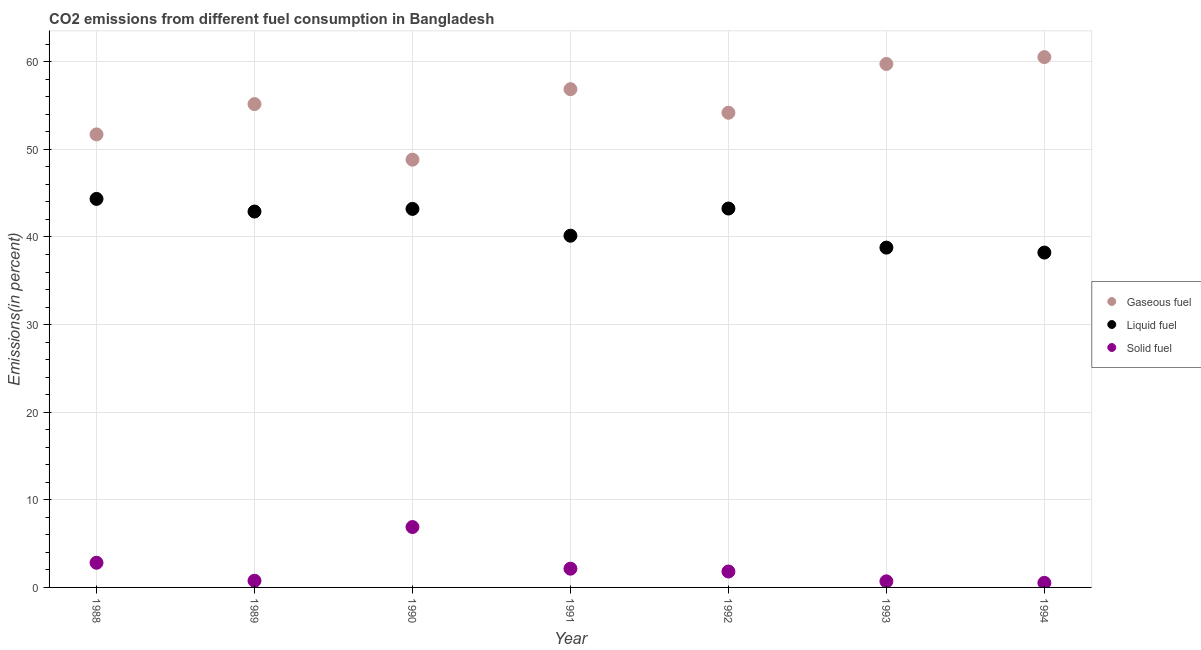How many different coloured dotlines are there?
Ensure brevity in your answer.  3. What is the percentage of liquid fuel emission in 1989?
Provide a short and direct response. 42.9. Across all years, what is the maximum percentage of liquid fuel emission?
Make the answer very short. 44.34. Across all years, what is the minimum percentage of liquid fuel emission?
Your answer should be very brief. 38.22. What is the total percentage of solid fuel emission in the graph?
Keep it short and to the point. 15.65. What is the difference between the percentage of liquid fuel emission in 1991 and that in 1993?
Offer a terse response. 1.36. What is the difference between the percentage of liquid fuel emission in 1994 and the percentage of gaseous fuel emission in 1993?
Offer a very short reply. -21.53. What is the average percentage of gaseous fuel emission per year?
Provide a short and direct response. 55.29. In the year 1988, what is the difference between the percentage of gaseous fuel emission and percentage of liquid fuel emission?
Give a very brief answer. 7.36. What is the ratio of the percentage of gaseous fuel emission in 1992 to that in 1994?
Your response must be concise. 0.9. Is the percentage of solid fuel emission in 1991 less than that in 1994?
Your answer should be compact. No. Is the difference between the percentage of liquid fuel emission in 1992 and 1993 greater than the difference between the percentage of solid fuel emission in 1992 and 1993?
Provide a succinct answer. Yes. What is the difference between the highest and the second highest percentage of gaseous fuel emission?
Give a very brief answer. 0.78. What is the difference between the highest and the lowest percentage of liquid fuel emission?
Offer a terse response. 6.12. Is the sum of the percentage of solid fuel emission in 1990 and 1992 greater than the maximum percentage of gaseous fuel emission across all years?
Make the answer very short. No. Does the percentage of solid fuel emission monotonically increase over the years?
Ensure brevity in your answer.  No. Is the percentage of gaseous fuel emission strictly greater than the percentage of liquid fuel emission over the years?
Make the answer very short. Yes. Are the values on the major ticks of Y-axis written in scientific E-notation?
Provide a short and direct response. No. Does the graph contain any zero values?
Give a very brief answer. No. How many legend labels are there?
Provide a succinct answer. 3. What is the title of the graph?
Give a very brief answer. CO2 emissions from different fuel consumption in Bangladesh. What is the label or title of the Y-axis?
Make the answer very short. Emissions(in percent). What is the Emissions(in percent) in Gaseous fuel in 1988?
Your response must be concise. 51.71. What is the Emissions(in percent) of Liquid fuel in 1988?
Ensure brevity in your answer.  44.34. What is the Emissions(in percent) in Solid fuel in 1988?
Provide a short and direct response. 2.82. What is the Emissions(in percent) in Gaseous fuel in 1989?
Offer a terse response. 55.16. What is the Emissions(in percent) of Liquid fuel in 1989?
Your answer should be compact. 42.9. What is the Emissions(in percent) in Solid fuel in 1989?
Provide a succinct answer. 0.76. What is the Emissions(in percent) of Gaseous fuel in 1990?
Your response must be concise. 48.82. What is the Emissions(in percent) in Liquid fuel in 1990?
Offer a terse response. 43.2. What is the Emissions(in percent) of Solid fuel in 1990?
Your answer should be very brief. 6.89. What is the Emissions(in percent) in Gaseous fuel in 1991?
Offer a terse response. 56.87. What is the Emissions(in percent) of Liquid fuel in 1991?
Provide a succinct answer. 40.14. What is the Emissions(in percent) in Solid fuel in 1991?
Give a very brief answer. 2.14. What is the Emissions(in percent) in Gaseous fuel in 1992?
Your response must be concise. 54.17. What is the Emissions(in percent) in Liquid fuel in 1992?
Offer a very short reply. 43.24. What is the Emissions(in percent) in Solid fuel in 1992?
Offer a very short reply. 1.82. What is the Emissions(in percent) of Gaseous fuel in 1993?
Make the answer very short. 59.74. What is the Emissions(in percent) of Liquid fuel in 1993?
Provide a succinct answer. 38.78. What is the Emissions(in percent) in Solid fuel in 1993?
Offer a very short reply. 0.7. What is the Emissions(in percent) of Gaseous fuel in 1994?
Keep it short and to the point. 60.53. What is the Emissions(in percent) in Liquid fuel in 1994?
Provide a short and direct response. 38.22. What is the Emissions(in percent) of Solid fuel in 1994?
Your answer should be very brief. 0.52. Across all years, what is the maximum Emissions(in percent) of Gaseous fuel?
Give a very brief answer. 60.53. Across all years, what is the maximum Emissions(in percent) of Liquid fuel?
Your answer should be very brief. 44.34. Across all years, what is the maximum Emissions(in percent) in Solid fuel?
Give a very brief answer. 6.89. Across all years, what is the minimum Emissions(in percent) in Gaseous fuel?
Keep it short and to the point. 48.82. Across all years, what is the minimum Emissions(in percent) in Liquid fuel?
Give a very brief answer. 38.22. Across all years, what is the minimum Emissions(in percent) of Solid fuel?
Provide a succinct answer. 0.52. What is the total Emissions(in percent) in Gaseous fuel in the graph?
Your response must be concise. 387. What is the total Emissions(in percent) in Liquid fuel in the graph?
Ensure brevity in your answer.  290.83. What is the total Emissions(in percent) of Solid fuel in the graph?
Provide a short and direct response. 15.65. What is the difference between the Emissions(in percent) in Gaseous fuel in 1988 and that in 1989?
Offer a very short reply. -3.46. What is the difference between the Emissions(in percent) in Liquid fuel in 1988 and that in 1989?
Keep it short and to the point. 1.44. What is the difference between the Emissions(in percent) of Solid fuel in 1988 and that in 1989?
Provide a short and direct response. 2.05. What is the difference between the Emissions(in percent) of Gaseous fuel in 1988 and that in 1990?
Your answer should be compact. 2.89. What is the difference between the Emissions(in percent) in Liquid fuel in 1988 and that in 1990?
Give a very brief answer. 1.14. What is the difference between the Emissions(in percent) of Solid fuel in 1988 and that in 1990?
Your response must be concise. -4.08. What is the difference between the Emissions(in percent) of Gaseous fuel in 1988 and that in 1991?
Your answer should be very brief. -5.16. What is the difference between the Emissions(in percent) in Liquid fuel in 1988 and that in 1991?
Offer a very short reply. 4.2. What is the difference between the Emissions(in percent) in Solid fuel in 1988 and that in 1991?
Your answer should be very brief. 0.68. What is the difference between the Emissions(in percent) in Gaseous fuel in 1988 and that in 1992?
Give a very brief answer. -2.47. What is the difference between the Emissions(in percent) of Liquid fuel in 1988 and that in 1992?
Your response must be concise. 1.1. What is the difference between the Emissions(in percent) in Solid fuel in 1988 and that in 1992?
Provide a succinct answer. 1. What is the difference between the Emissions(in percent) of Gaseous fuel in 1988 and that in 1993?
Make the answer very short. -8.04. What is the difference between the Emissions(in percent) of Liquid fuel in 1988 and that in 1993?
Offer a very short reply. 5.56. What is the difference between the Emissions(in percent) of Solid fuel in 1988 and that in 1993?
Your answer should be compact. 2.12. What is the difference between the Emissions(in percent) of Gaseous fuel in 1988 and that in 1994?
Provide a succinct answer. -8.82. What is the difference between the Emissions(in percent) of Liquid fuel in 1988 and that in 1994?
Offer a terse response. 6.12. What is the difference between the Emissions(in percent) in Solid fuel in 1988 and that in 1994?
Offer a very short reply. 2.29. What is the difference between the Emissions(in percent) of Gaseous fuel in 1989 and that in 1990?
Offer a terse response. 6.35. What is the difference between the Emissions(in percent) of Liquid fuel in 1989 and that in 1990?
Keep it short and to the point. -0.3. What is the difference between the Emissions(in percent) of Solid fuel in 1989 and that in 1990?
Your response must be concise. -6.13. What is the difference between the Emissions(in percent) in Gaseous fuel in 1989 and that in 1991?
Your response must be concise. -1.7. What is the difference between the Emissions(in percent) of Liquid fuel in 1989 and that in 1991?
Keep it short and to the point. 2.76. What is the difference between the Emissions(in percent) of Solid fuel in 1989 and that in 1991?
Provide a short and direct response. -1.38. What is the difference between the Emissions(in percent) in Gaseous fuel in 1989 and that in 1992?
Offer a terse response. 0.99. What is the difference between the Emissions(in percent) in Liquid fuel in 1989 and that in 1992?
Offer a terse response. -0.34. What is the difference between the Emissions(in percent) in Solid fuel in 1989 and that in 1992?
Your response must be concise. -1.05. What is the difference between the Emissions(in percent) in Gaseous fuel in 1989 and that in 1993?
Offer a terse response. -4.58. What is the difference between the Emissions(in percent) in Liquid fuel in 1989 and that in 1993?
Keep it short and to the point. 4.12. What is the difference between the Emissions(in percent) of Solid fuel in 1989 and that in 1993?
Your response must be concise. 0.07. What is the difference between the Emissions(in percent) of Gaseous fuel in 1989 and that in 1994?
Offer a terse response. -5.36. What is the difference between the Emissions(in percent) of Liquid fuel in 1989 and that in 1994?
Give a very brief answer. 4.68. What is the difference between the Emissions(in percent) of Solid fuel in 1989 and that in 1994?
Provide a short and direct response. 0.24. What is the difference between the Emissions(in percent) of Gaseous fuel in 1990 and that in 1991?
Your response must be concise. -8.05. What is the difference between the Emissions(in percent) of Liquid fuel in 1990 and that in 1991?
Your answer should be compact. 3.06. What is the difference between the Emissions(in percent) of Solid fuel in 1990 and that in 1991?
Offer a terse response. 4.75. What is the difference between the Emissions(in percent) in Gaseous fuel in 1990 and that in 1992?
Offer a terse response. -5.35. What is the difference between the Emissions(in percent) in Liquid fuel in 1990 and that in 1992?
Your answer should be compact. -0.04. What is the difference between the Emissions(in percent) in Solid fuel in 1990 and that in 1992?
Offer a terse response. 5.08. What is the difference between the Emissions(in percent) in Gaseous fuel in 1990 and that in 1993?
Make the answer very short. -10.92. What is the difference between the Emissions(in percent) in Liquid fuel in 1990 and that in 1993?
Provide a succinct answer. 4.42. What is the difference between the Emissions(in percent) of Solid fuel in 1990 and that in 1993?
Your answer should be compact. 6.2. What is the difference between the Emissions(in percent) of Gaseous fuel in 1990 and that in 1994?
Provide a succinct answer. -11.71. What is the difference between the Emissions(in percent) in Liquid fuel in 1990 and that in 1994?
Provide a succinct answer. 4.98. What is the difference between the Emissions(in percent) in Solid fuel in 1990 and that in 1994?
Offer a terse response. 6.37. What is the difference between the Emissions(in percent) of Gaseous fuel in 1991 and that in 1992?
Offer a very short reply. 2.69. What is the difference between the Emissions(in percent) of Liquid fuel in 1991 and that in 1992?
Provide a succinct answer. -3.1. What is the difference between the Emissions(in percent) in Solid fuel in 1991 and that in 1992?
Your answer should be very brief. 0.32. What is the difference between the Emissions(in percent) of Gaseous fuel in 1991 and that in 1993?
Make the answer very short. -2.88. What is the difference between the Emissions(in percent) in Liquid fuel in 1991 and that in 1993?
Provide a succinct answer. 1.36. What is the difference between the Emissions(in percent) of Solid fuel in 1991 and that in 1993?
Make the answer very short. 1.44. What is the difference between the Emissions(in percent) in Gaseous fuel in 1991 and that in 1994?
Provide a short and direct response. -3.66. What is the difference between the Emissions(in percent) in Liquid fuel in 1991 and that in 1994?
Give a very brief answer. 1.93. What is the difference between the Emissions(in percent) of Solid fuel in 1991 and that in 1994?
Keep it short and to the point. 1.62. What is the difference between the Emissions(in percent) of Gaseous fuel in 1992 and that in 1993?
Make the answer very short. -5.57. What is the difference between the Emissions(in percent) in Liquid fuel in 1992 and that in 1993?
Provide a succinct answer. 4.46. What is the difference between the Emissions(in percent) in Solid fuel in 1992 and that in 1993?
Provide a short and direct response. 1.12. What is the difference between the Emissions(in percent) of Gaseous fuel in 1992 and that in 1994?
Ensure brevity in your answer.  -6.35. What is the difference between the Emissions(in percent) of Liquid fuel in 1992 and that in 1994?
Provide a short and direct response. 5.03. What is the difference between the Emissions(in percent) in Solid fuel in 1992 and that in 1994?
Provide a short and direct response. 1.3. What is the difference between the Emissions(in percent) in Gaseous fuel in 1993 and that in 1994?
Provide a succinct answer. -0.78. What is the difference between the Emissions(in percent) in Liquid fuel in 1993 and that in 1994?
Offer a terse response. 0.56. What is the difference between the Emissions(in percent) of Solid fuel in 1993 and that in 1994?
Your response must be concise. 0.17. What is the difference between the Emissions(in percent) of Gaseous fuel in 1988 and the Emissions(in percent) of Liquid fuel in 1989?
Provide a short and direct response. 8.81. What is the difference between the Emissions(in percent) in Gaseous fuel in 1988 and the Emissions(in percent) in Solid fuel in 1989?
Your response must be concise. 50.94. What is the difference between the Emissions(in percent) in Liquid fuel in 1988 and the Emissions(in percent) in Solid fuel in 1989?
Your answer should be compact. 43.58. What is the difference between the Emissions(in percent) in Gaseous fuel in 1988 and the Emissions(in percent) in Liquid fuel in 1990?
Your response must be concise. 8.5. What is the difference between the Emissions(in percent) in Gaseous fuel in 1988 and the Emissions(in percent) in Solid fuel in 1990?
Your answer should be very brief. 44.81. What is the difference between the Emissions(in percent) of Liquid fuel in 1988 and the Emissions(in percent) of Solid fuel in 1990?
Give a very brief answer. 37.45. What is the difference between the Emissions(in percent) of Gaseous fuel in 1988 and the Emissions(in percent) of Liquid fuel in 1991?
Ensure brevity in your answer.  11.56. What is the difference between the Emissions(in percent) in Gaseous fuel in 1988 and the Emissions(in percent) in Solid fuel in 1991?
Offer a very short reply. 49.57. What is the difference between the Emissions(in percent) in Liquid fuel in 1988 and the Emissions(in percent) in Solid fuel in 1991?
Keep it short and to the point. 42.2. What is the difference between the Emissions(in percent) of Gaseous fuel in 1988 and the Emissions(in percent) of Liquid fuel in 1992?
Give a very brief answer. 8.46. What is the difference between the Emissions(in percent) in Gaseous fuel in 1988 and the Emissions(in percent) in Solid fuel in 1992?
Ensure brevity in your answer.  49.89. What is the difference between the Emissions(in percent) in Liquid fuel in 1988 and the Emissions(in percent) in Solid fuel in 1992?
Offer a very short reply. 42.52. What is the difference between the Emissions(in percent) in Gaseous fuel in 1988 and the Emissions(in percent) in Liquid fuel in 1993?
Your answer should be compact. 12.92. What is the difference between the Emissions(in percent) in Gaseous fuel in 1988 and the Emissions(in percent) in Solid fuel in 1993?
Provide a short and direct response. 51.01. What is the difference between the Emissions(in percent) in Liquid fuel in 1988 and the Emissions(in percent) in Solid fuel in 1993?
Provide a short and direct response. 43.65. What is the difference between the Emissions(in percent) of Gaseous fuel in 1988 and the Emissions(in percent) of Liquid fuel in 1994?
Offer a terse response. 13.49. What is the difference between the Emissions(in percent) of Gaseous fuel in 1988 and the Emissions(in percent) of Solid fuel in 1994?
Your answer should be compact. 51.18. What is the difference between the Emissions(in percent) in Liquid fuel in 1988 and the Emissions(in percent) in Solid fuel in 1994?
Offer a very short reply. 43.82. What is the difference between the Emissions(in percent) of Gaseous fuel in 1989 and the Emissions(in percent) of Liquid fuel in 1990?
Keep it short and to the point. 11.96. What is the difference between the Emissions(in percent) of Gaseous fuel in 1989 and the Emissions(in percent) of Solid fuel in 1990?
Offer a very short reply. 48.27. What is the difference between the Emissions(in percent) of Liquid fuel in 1989 and the Emissions(in percent) of Solid fuel in 1990?
Provide a short and direct response. 36.01. What is the difference between the Emissions(in percent) of Gaseous fuel in 1989 and the Emissions(in percent) of Liquid fuel in 1991?
Provide a short and direct response. 15.02. What is the difference between the Emissions(in percent) of Gaseous fuel in 1989 and the Emissions(in percent) of Solid fuel in 1991?
Keep it short and to the point. 53.03. What is the difference between the Emissions(in percent) in Liquid fuel in 1989 and the Emissions(in percent) in Solid fuel in 1991?
Offer a terse response. 40.76. What is the difference between the Emissions(in percent) in Gaseous fuel in 1989 and the Emissions(in percent) in Liquid fuel in 1992?
Your answer should be compact. 11.92. What is the difference between the Emissions(in percent) of Gaseous fuel in 1989 and the Emissions(in percent) of Solid fuel in 1992?
Keep it short and to the point. 53.35. What is the difference between the Emissions(in percent) in Liquid fuel in 1989 and the Emissions(in percent) in Solid fuel in 1992?
Make the answer very short. 41.08. What is the difference between the Emissions(in percent) in Gaseous fuel in 1989 and the Emissions(in percent) in Liquid fuel in 1993?
Provide a short and direct response. 16.38. What is the difference between the Emissions(in percent) in Gaseous fuel in 1989 and the Emissions(in percent) in Solid fuel in 1993?
Provide a short and direct response. 54.47. What is the difference between the Emissions(in percent) in Liquid fuel in 1989 and the Emissions(in percent) in Solid fuel in 1993?
Give a very brief answer. 42.2. What is the difference between the Emissions(in percent) of Gaseous fuel in 1989 and the Emissions(in percent) of Liquid fuel in 1994?
Your response must be concise. 16.95. What is the difference between the Emissions(in percent) of Gaseous fuel in 1989 and the Emissions(in percent) of Solid fuel in 1994?
Your answer should be compact. 54.64. What is the difference between the Emissions(in percent) of Liquid fuel in 1989 and the Emissions(in percent) of Solid fuel in 1994?
Offer a very short reply. 42.38. What is the difference between the Emissions(in percent) in Gaseous fuel in 1990 and the Emissions(in percent) in Liquid fuel in 1991?
Provide a short and direct response. 8.68. What is the difference between the Emissions(in percent) in Gaseous fuel in 1990 and the Emissions(in percent) in Solid fuel in 1991?
Provide a short and direct response. 46.68. What is the difference between the Emissions(in percent) in Liquid fuel in 1990 and the Emissions(in percent) in Solid fuel in 1991?
Offer a very short reply. 41.06. What is the difference between the Emissions(in percent) of Gaseous fuel in 1990 and the Emissions(in percent) of Liquid fuel in 1992?
Ensure brevity in your answer.  5.58. What is the difference between the Emissions(in percent) in Gaseous fuel in 1990 and the Emissions(in percent) in Solid fuel in 1992?
Offer a very short reply. 47. What is the difference between the Emissions(in percent) of Liquid fuel in 1990 and the Emissions(in percent) of Solid fuel in 1992?
Keep it short and to the point. 41.38. What is the difference between the Emissions(in percent) in Gaseous fuel in 1990 and the Emissions(in percent) in Liquid fuel in 1993?
Your response must be concise. 10.04. What is the difference between the Emissions(in percent) in Gaseous fuel in 1990 and the Emissions(in percent) in Solid fuel in 1993?
Give a very brief answer. 48.12. What is the difference between the Emissions(in percent) of Liquid fuel in 1990 and the Emissions(in percent) of Solid fuel in 1993?
Your answer should be compact. 42.51. What is the difference between the Emissions(in percent) in Gaseous fuel in 1990 and the Emissions(in percent) in Liquid fuel in 1994?
Offer a very short reply. 10.6. What is the difference between the Emissions(in percent) of Gaseous fuel in 1990 and the Emissions(in percent) of Solid fuel in 1994?
Your answer should be very brief. 48.3. What is the difference between the Emissions(in percent) in Liquid fuel in 1990 and the Emissions(in percent) in Solid fuel in 1994?
Keep it short and to the point. 42.68. What is the difference between the Emissions(in percent) in Gaseous fuel in 1991 and the Emissions(in percent) in Liquid fuel in 1992?
Make the answer very short. 13.62. What is the difference between the Emissions(in percent) of Gaseous fuel in 1991 and the Emissions(in percent) of Solid fuel in 1992?
Keep it short and to the point. 55.05. What is the difference between the Emissions(in percent) of Liquid fuel in 1991 and the Emissions(in percent) of Solid fuel in 1992?
Keep it short and to the point. 38.32. What is the difference between the Emissions(in percent) in Gaseous fuel in 1991 and the Emissions(in percent) in Liquid fuel in 1993?
Provide a succinct answer. 18.08. What is the difference between the Emissions(in percent) of Gaseous fuel in 1991 and the Emissions(in percent) of Solid fuel in 1993?
Your response must be concise. 56.17. What is the difference between the Emissions(in percent) in Liquid fuel in 1991 and the Emissions(in percent) in Solid fuel in 1993?
Offer a terse response. 39.45. What is the difference between the Emissions(in percent) of Gaseous fuel in 1991 and the Emissions(in percent) of Liquid fuel in 1994?
Provide a succinct answer. 18.65. What is the difference between the Emissions(in percent) in Gaseous fuel in 1991 and the Emissions(in percent) in Solid fuel in 1994?
Provide a short and direct response. 56.34. What is the difference between the Emissions(in percent) in Liquid fuel in 1991 and the Emissions(in percent) in Solid fuel in 1994?
Make the answer very short. 39.62. What is the difference between the Emissions(in percent) in Gaseous fuel in 1992 and the Emissions(in percent) in Liquid fuel in 1993?
Ensure brevity in your answer.  15.39. What is the difference between the Emissions(in percent) of Gaseous fuel in 1992 and the Emissions(in percent) of Solid fuel in 1993?
Your response must be concise. 53.48. What is the difference between the Emissions(in percent) of Liquid fuel in 1992 and the Emissions(in percent) of Solid fuel in 1993?
Make the answer very short. 42.55. What is the difference between the Emissions(in percent) in Gaseous fuel in 1992 and the Emissions(in percent) in Liquid fuel in 1994?
Give a very brief answer. 15.96. What is the difference between the Emissions(in percent) in Gaseous fuel in 1992 and the Emissions(in percent) in Solid fuel in 1994?
Your answer should be compact. 53.65. What is the difference between the Emissions(in percent) of Liquid fuel in 1992 and the Emissions(in percent) of Solid fuel in 1994?
Offer a terse response. 42.72. What is the difference between the Emissions(in percent) in Gaseous fuel in 1993 and the Emissions(in percent) in Liquid fuel in 1994?
Keep it short and to the point. 21.53. What is the difference between the Emissions(in percent) in Gaseous fuel in 1993 and the Emissions(in percent) in Solid fuel in 1994?
Your answer should be very brief. 59.22. What is the difference between the Emissions(in percent) of Liquid fuel in 1993 and the Emissions(in percent) of Solid fuel in 1994?
Make the answer very short. 38.26. What is the average Emissions(in percent) in Gaseous fuel per year?
Offer a terse response. 55.29. What is the average Emissions(in percent) in Liquid fuel per year?
Keep it short and to the point. 41.55. What is the average Emissions(in percent) in Solid fuel per year?
Give a very brief answer. 2.24. In the year 1988, what is the difference between the Emissions(in percent) of Gaseous fuel and Emissions(in percent) of Liquid fuel?
Your response must be concise. 7.36. In the year 1988, what is the difference between the Emissions(in percent) in Gaseous fuel and Emissions(in percent) in Solid fuel?
Ensure brevity in your answer.  48.89. In the year 1988, what is the difference between the Emissions(in percent) of Liquid fuel and Emissions(in percent) of Solid fuel?
Your response must be concise. 41.53. In the year 1989, what is the difference between the Emissions(in percent) of Gaseous fuel and Emissions(in percent) of Liquid fuel?
Your response must be concise. 12.26. In the year 1989, what is the difference between the Emissions(in percent) in Gaseous fuel and Emissions(in percent) in Solid fuel?
Make the answer very short. 54.4. In the year 1989, what is the difference between the Emissions(in percent) in Liquid fuel and Emissions(in percent) in Solid fuel?
Your response must be concise. 42.14. In the year 1990, what is the difference between the Emissions(in percent) in Gaseous fuel and Emissions(in percent) in Liquid fuel?
Give a very brief answer. 5.62. In the year 1990, what is the difference between the Emissions(in percent) in Gaseous fuel and Emissions(in percent) in Solid fuel?
Ensure brevity in your answer.  41.93. In the year 1990, what is the difference between the Emissions(in percent) of Liquid fuel and Emissions(in percent) of Solid fuel?
Make the answer very short. 36.31. In the year 1991, what is the difference between the Emissions(in percent) of Gaseous fuel and Emissions(in percent) of Liquid fuel?
Keep it short and to the point. 16.72. In the year 1991, what is the difference between the Emissions(in percent) in Gaseous fuel and Emissions(in percent) in Solid fuel?
Ensure brevity in your answer.  54.73. In the year 1991, what is the difference between the Emissions(in percent) of Liquid fuel and Emissions(in percent) of Solid fuel?
Give a very brief answer. 38. In the year 1992, what is the difference between the Emissions(in percent) in Gaseous fuel and Emissions(in percent) in Liquid fuel?
Your answer should be very brief. 10.93. In the year 1992, what is the difference between the Emissions(in percent) of Gaseous fuel and Emissions(in percent) of Solid fuel?
Offer a terse response. 52.36. In the year 1992, what is the difference between the Emissions(in percent) of Liquid fuel and Emissions(in percent) of Solid fuel?
Provide a short and direct response. 41.43. In the year 1993, what is the difference between the Emissions(in percent) of Gaseous fuel and Emissions(in percent) of Liquid fuel?
Make the answer very short. 20.96. In the year 1993, what is the difference between the Emissions(in percent) in Gaseous fuel and Emissions(in percent) in Solid fuel?
Keep it short and to the point. 59.05. In the year 1993, what is the difference between the Emissions(in percent) of Liquid fuel and Emissions(in percent) of Solid fuel?
Your response must be concise. 38.09. In the year 1994, what is the difference between the Emissions(in percent) in Gaseous fuel and Emissions(in percent) in Liquid fuel?
Give a very brief answer. 22.31. In the year 1994, what is the difference between the Emissions(in percent) in Gaseous fuel and Emissions(in percent) in Solid fuel?
Make the answer very short. 60. In the year 1994, what is the difference between the Emissions(in percent) in Liquid fuel and Emissions(in percent) in Solid fuel?
Ensure brevity in your answer.  37.7. What is the ratio of the Emissions(in percent) of Gaseous fuel in 1988 to that in 1989?
Your response must be concise. 0.94. What is the ratio of the Emissions(in percent) of Liquid fuel in 1988 to that in 1989?
Provide a succinct answer. 1.03. What is the ratio of the Emissions(in percent) of Solid fuel in 1988 to that in 1989?
Provide a succinct answer. 3.69. What is the ratio of the Emissions(in percent) in Gaseous fuel in 1988 to that in 1990?
Your response must be concise. 1.06. What is the ratio of the Emissions(in percent) in Liquid fuel in 1988 to that in 1990?
Provide a succinct answer. 1.03. What is the ratio of the Emissions(in percent) in Solid fuel in 1988 to that in 1990?
Make the answer very short. 0.41. What is the ratio of the Emissions(in percent) of Gaseous fuel in 1988 to that in 1991?
Provide a succinct answer. 0.91. What is the ratio of the Emissions(in percent) of Liquid fuel in 1988 to that in 1991?
Ensure brevity in your answer.  1.1. What is the ratio of the Emissions(in percent) in Solid fuel in 1988 to that in 1991?
Your response must be concise. 1.32. What is the ratio of the Emissions(in percent) in Gaseous fuel in 1988 to that in 1992?
Provide a short and direct response. 0.95. What is the ratio of the Emissions(in percent) in Liquid fuel in 1988 to that in 1992?
Make the answer very short. 1.03. What is the ratio of the Emissions(in percent) of Solid fuel in 1988 to that in 1992?
Offer a terse response. 1.55. What is the ratio of the Emissions(in percent) of Gaseous fuel in 1988 to that in 1993?
Your answer should be compact. 0.87. What is the ratio of the Emissions(in percent) in Liquid fuel in 1988 to that in 1993?
Your answer should be very brief. 1.14. What is the ratio of the Emissions(in percent) of Solid fuel in 1988 to that in 1993?
Keep it short and to the point. 4.05. What is the ratio of the Emissions(in percent) of Gaseous fuel in 1988 to that in 1994?
Offer a very short reply. 0.85. What is the ratio of the Emissions(in percent) in Liquid fuel in 1988 to that in 1994?
Provide a succinct answer. 1.16. What is the ratio of the Emissions(in percent) of Solid fuel in 1988 to that in 1994?
Keep it short and to the point. 5.39. What is the ratio of the Emissions(in percent) of Gaseous fuel in 1989 to that in 1990?
Offer a terse response. 1.13. What is the ratio of the Emissions(in percent) in Liquid fuel in 1989 to that in 1990?
Make the answer very short. 0.99. What is the ratio of the Emissions(in percent) of Solid fuel in 1989 to that in 1990?
Offer a terse response. 0.11. What is the ratio of the Emissions(in percent) of Gaseous fuel in 1989 to that in 1991?
Provide a short and direct response. 0.97. What is the ratio of the Emissions(in percent) in Liquid fuel in 1989 to that in 1991?
Offer a terse response. 1.07. What is the ratio of the Emissions(in percent) in Solid fuel in 1989 to that in 1991?
Keep it short and to the point. 0.36. What is the ratio of the Emissions(in percent) of Gaseous fuel in 1989 to that in 1992?
Keep it short and to the point. 1.02. What is the ratio of the Emissions(in percent) of Liquid fuel in 1989 to that in 1992?
Offer a terse response. 0.99. What is the ratio of the Emissions(in percent) of Solid fuel in 1989 to that in 1992?
Offer a terse response. 0.42. What is the ratio of the Emissions(in percent) of Gaseous fuel in 1989 to that in 1993?
Provide a short and direct response. 0.92. What is the ratio of the Emissions(in percent) of Liquid fuel in 1989 to that in 1993?
Provide a succinct answer. 1.11. What is the ratio of the Emissions(in percent) of Solid fuel in 1989 to that in 1993?
Offer a terse response. 1.1. What is the ratio of the Emissions(in percent) in Gaseous fuel in 1989 to that in 1994?
Your answer should be compact. 0.91. What is the ratio of the Emissions(in percent) in Liquid fuel in 1989 to that in 1994?
Provide a succinct answer. 1.12. What is the ratio of the Emissions(in percent) in Solid fuel in 1989 to that in 1994?
Your response must be concise. 1.46. What is the ratio of the Emissions(in percent) in Gaseous fuel in 1990 to that in 1991?
Ensure brevity in your answer.  0.86. What is the ratio of the Emissions(in percent) of Liquid fuel in 1990 to that in 1991?
Your answer should be compact. 1.08. What is the ratio of the Emissions(in percent) in Solid fuel in 1990 to that in 1991?
Keep it short and to the point. 3.22. What is the ratio of the Emissions(in percent) of Gaseous fuel in 1990 to that in 1992?
Your answer should be compact. 0.9. What is the ratio of the Emissions(in percent) in Solid fuel in 1990 to that in 1992?
Make the answer very short. 3.79. What is the ratio of the Emissions(in percent) in Gaseous fuel in 1990 to that in 1993?
Provide a short and direct response. 0.82. What is the ratio of the Emissions(in percent) in Liquid fuel in 1990 to that in 1993?
Provide a succinct answer. 1.11. What is the ratio of the Emissions(in percent) in Solid fuel in 1990 to that in 1993?
Provide a short and direct response. 9.92. What is the ratio of the Emissions(in percent) of Gaseous fuel in 1990 to that in 1994?
Offer a terse response. 0.81. What is the ratio of the Emissions(in percent) of Liquid fuel in 1990 to that in 1994?
Provide a succinct answer. 1.13. What is the ratio of the Emissions(in percent) of Solid fuel in 1990 to that in 1994?
Provide a short and direct response. 13.21. What is the ratio of the Emissions(in percent) in Gaseous fuel in 1991 to that in 1992?
Offer a very short reply. 1.05. What is the ratio of the Emissions(in percent) of Liquid fuel in 1991 to that in 1992?
Offer a terse response. 0.93. What is the ratio of the Emissions(in percent) in Solid fuel in 1991 to that in 1992?
Your answer should be compact. 1.18. What is the ratio of the Emissions(in percent) of Gaseous fuel in 1991 to that in 1993?
Keep it short and to the point. 0.95. What is the ratio of the Emissions(in percent) of Liquid fuel in 1991 to that in 1993?
Offer a very short reply. 1.04. What is the ratio of the Emissions(in percent) of Solid fuel in 1991 to that in 1993?
Provide a short and direct response. 3.08. What is the ratio of the Emissions(in percent) of Gaseous fuel in 1991 to that in 1994?
Offer a terse response. 0.94. What is the ratio of the Emissions(in percent) in Liquid fuel in 1991 to that in 1994?
Offer a terse response. 1.05. What is the ratio of the Emissions(in percent) of Solid fuel in 1991 to that in 1994?
Keep it short and to the point. 4.1. What is the ratio of the Emissions(in percent) in Gaseous fuel in 1992 to that in 1993?
Ensure brevity in your answer.  0.91. What is the ratio of the Emissions(in percent) of Liquid fuel in 1992 to that in 1993?
Ensure brevity in your answer.  1.11. What is the ratio of the Emissions(in percent) of Solid fuel in 1992 to that in 1993?
Provide a short and direct response. 2.62. What is the ratio of the Emissions(in percent) in Gaseous fuel in 1992 to that in 1994?
Give a very brief answer. 0.9. What is the ratio of the Emissions(in percent) in Liquid fuel in 1992 to that in 1994?
Ensure brevity in your answer.  1.13. What is the ratio of the Emissions(in percent) of Solid fuel in 1992 to that in 1994?
Give a very brief answer. 3.48. What is the ratio of the Emissions(in percent) of Gaseous fuel in 1993 to that in 1994?
Keep it short and to the point. 0.99. What is the ratio of the Emissions(in percent) in Liquid fuel in 1993 to that in 1994?
Keep it short and to the point. 1.01. What is the ratio of the Emissions(in percent) in Solid fuel in 1993 to that in 1994?
Give a very brief answer. 1.33. What is the difference between the highest and the second highest Emissions(in percent) of Gaseous fuel?
Keep it short and to the point. 0.78. What is the difference between the highest and the second highest Emissions(in percent) of Liquid fuel?
Make the answer very short. 1.1. What is the difference between the highest and the second highest Emissions(in percent) of Solid fuel?
Offer a very short reply. 4.08. What is the difference between the highest and the lowest Emissions(in percent) of Gaseous fuel?
Provide a short and direct response. 11.71. What is the difference between the highest and the lowest Emissions(in percent) in Liquid fuel?
Keep it short and to the point. 6.12. What is the difference between the highest and the lowest Emissions(in percent) in Solid fuel?
Offer a very short reply. 6.37. 